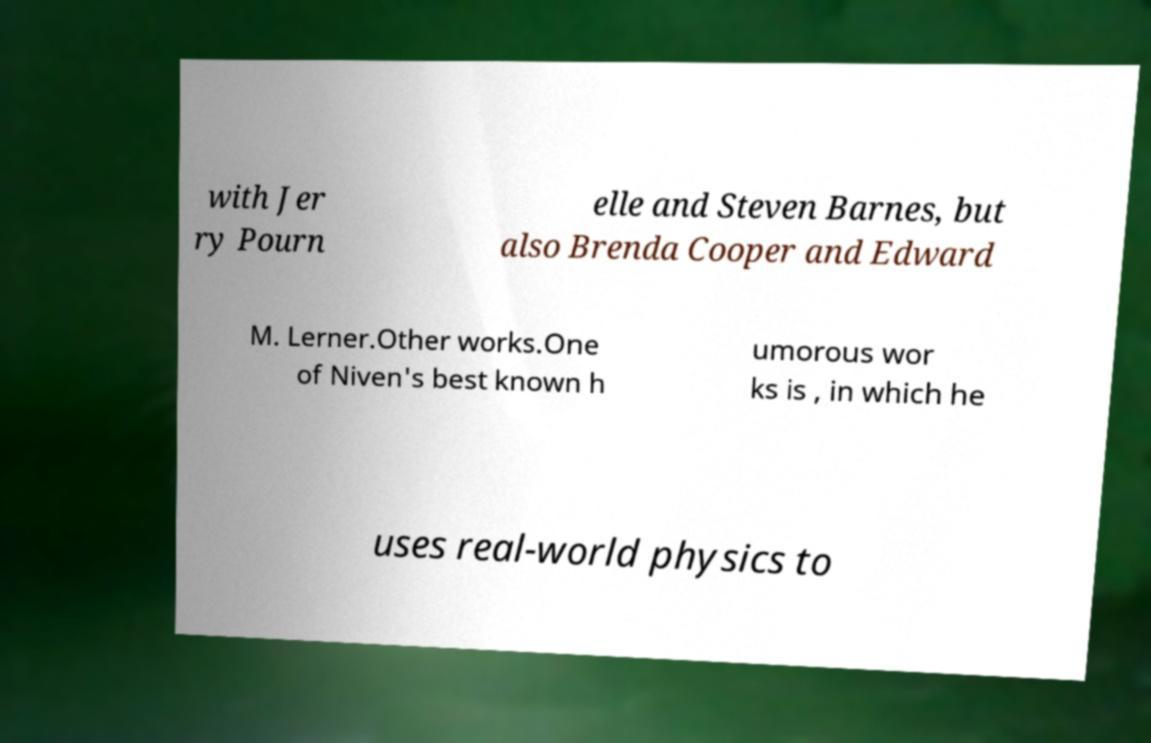What messages or text are displayed in this image? I need them in a readable, typed format. with Jer ry Pourn elle and Steven Barnes, but also Brenda Cooper and Edward M. Lerner.Other works.One of Niven's best known h umorous wor ks is , in which he uses real-world physics to 